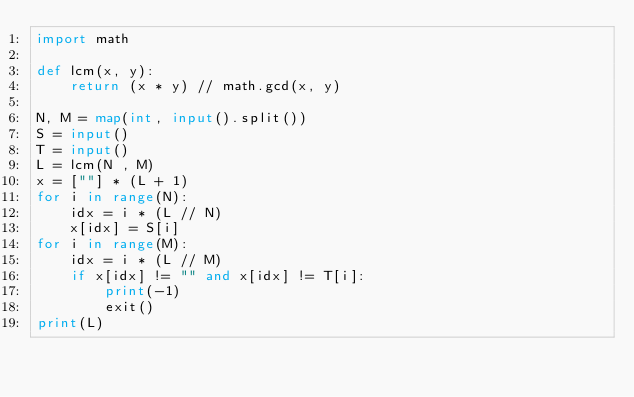Convert code to text. <code><loc_0><loc_0><loc_500><loc_500><_Python_>import math

def lcm(x, y):
    return (x * y) // math.gcd(x, y)

N, M = map(int, input().split())
S = input()
T = input()
L = lcm(N , M)
x = [""] * (L + 1)
for i in range(N):
    idx = i * (L // N)
    x[idx] = S[i]
for i in range(M):
    idx = i * (L // M)
    if x[idx] != "" and x[idx] != T[i]:
        print(-1)
        exit()
print(L)
</code> 